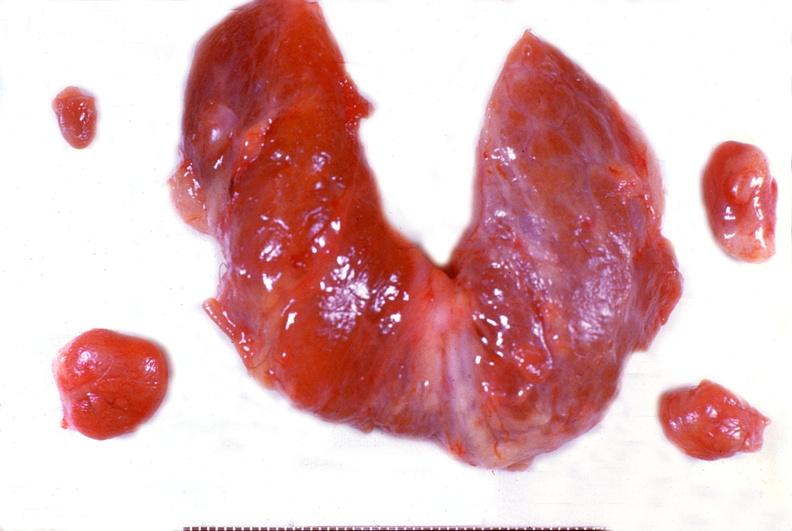what does this image show?
Answer the question using a single word or phrase. Parathyroid hyperplasia 